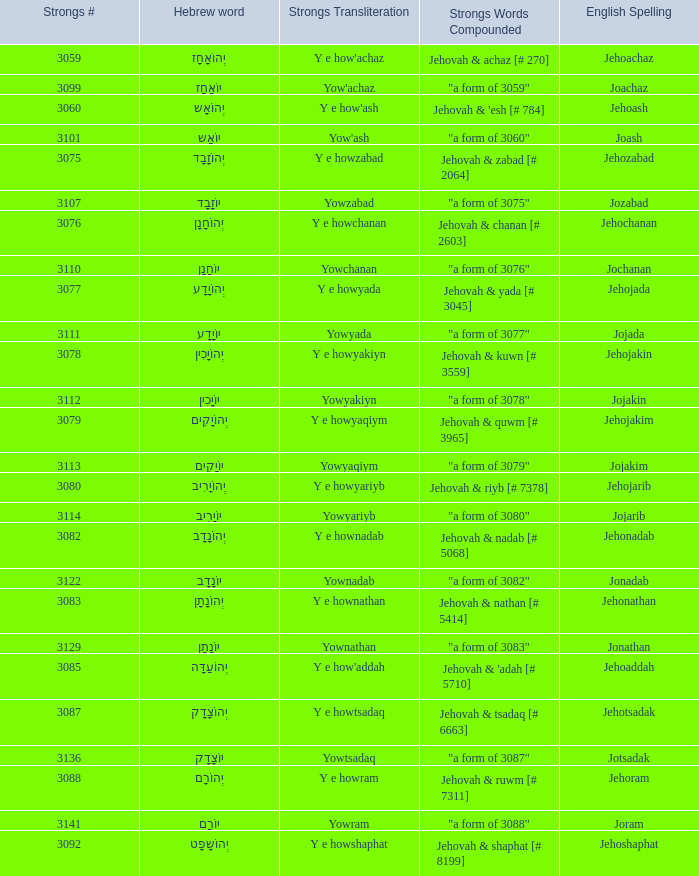What is the strongs # of the english spelling word jehojakin? 3078.0. 